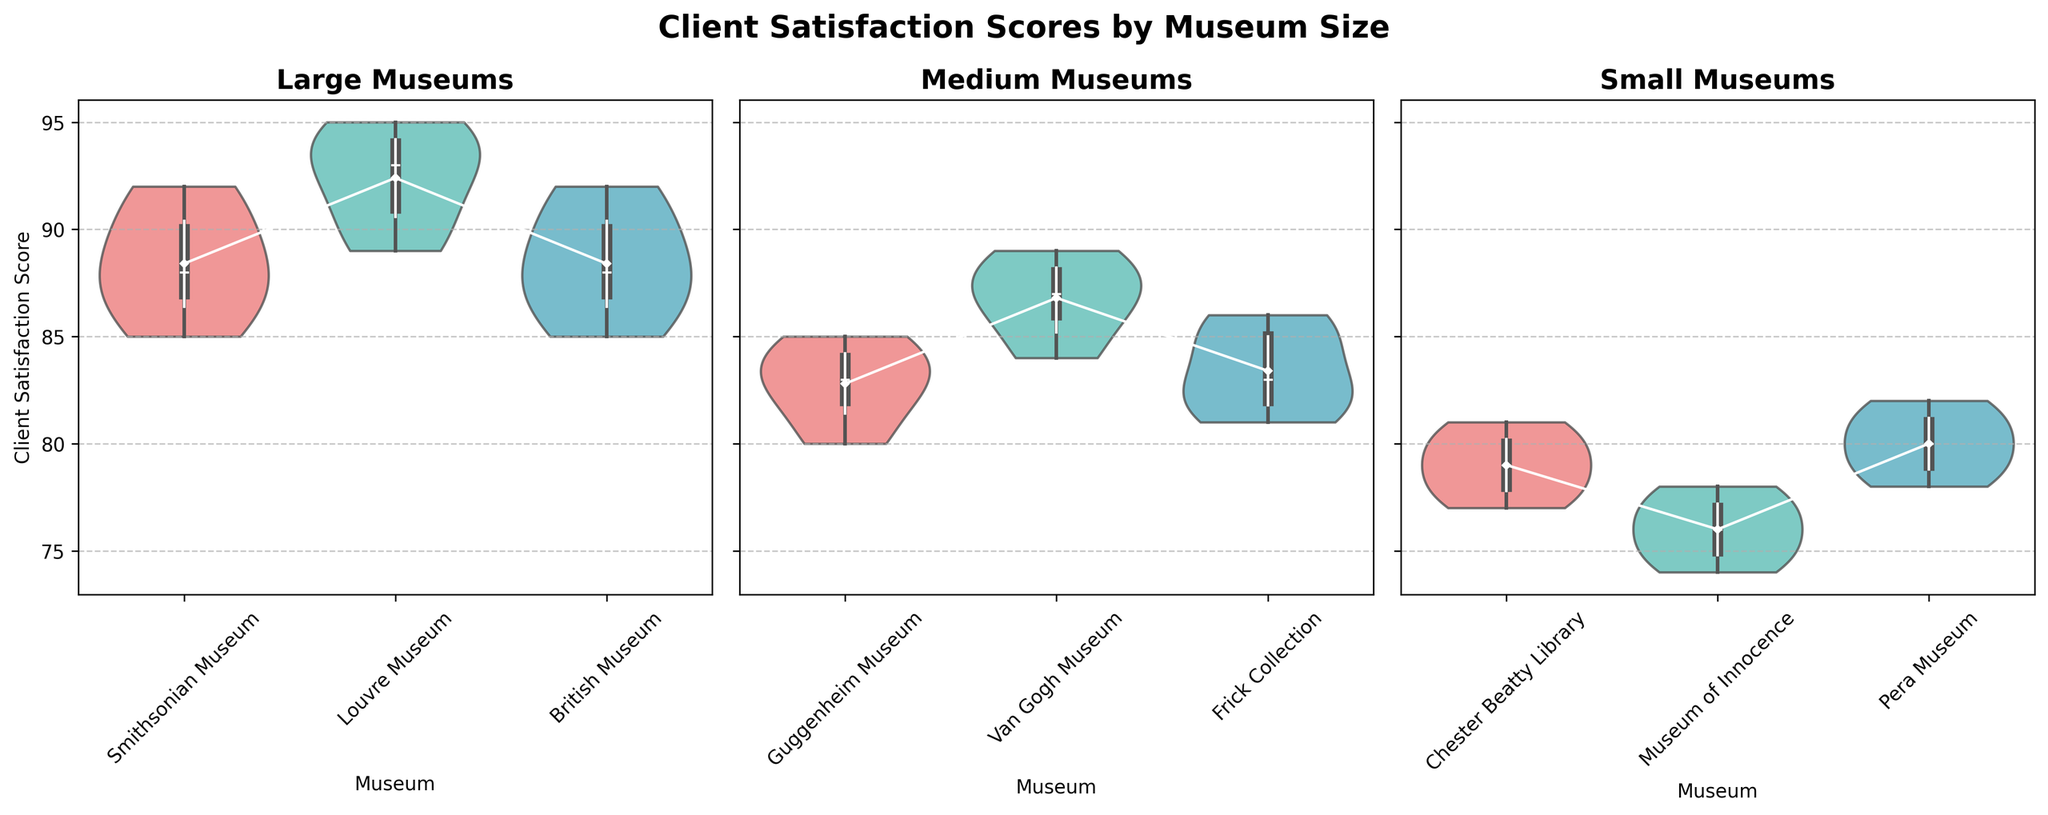What is the title of the plots? The title of the plots is found at the top of the figure. It reads "Client Satisfaction Scores by Museum Size". This indicates that the figure is comparing client satisfaction scores for museums of different sizes.
Answer: Client Satisfaction Scores by Museum Size Which museum among the large museums has the highest average client satisfaction score? To find this, we need to look at the positioning of the white diamonds (mean points) on the "Large Museums" subplot. Among the Smithsonian, Louvre, and British Museum, the Louvre Museum has the highest average, as indicated by the highest mean point.
Answer: Louvre Museum What is the range of client satisfaction scores for medium-sized museums? The range is determined by the minimum and maximum values in the violin plots for medium-sized museums. For the Guggenheim Museum, Van Gogh Museum, and Frick Collection, the minimum score is 80 and the maximum is 89 based on the extreme ends of the plots.
Answer: 80-89 Which museum size has the most varied client satisfaction scores? The variation can be assessed by the width of the violin plots. The small museums have the widest plots and the most spread out distribution of scores across the Chester Beatty Library, Museum of Innocence, and Pera Museum.
Answer: Small museums Do the larger museums tend to have higher client satisfaction scores compared to medium and small-sized museums? By comparing the general positioning of the violin plots, we can observe that the large museums generally have higher scores (mostly in the high 80s and 90s) compared to medium (mostly in 80s) and small museums (mostly in 70s to low 80s).
Answer: Yes Which medium-sized museum has the lowest average client satisfaction score? By checking the mean points (white diamonds) in the "Medium Museums" subplot, the lowest average score is observed in the Frick Collection.
Answer: Frick Collection Is there any overlap in the client satisfaction scores between the large and medium museums? Yes, there is overlap. The lower end of the large museum scores overlaps with the higher end of the medium museum scores, roughly between scores of 85 and 90.
Answer: Yes Which small museum has the highest client satisfaction score? By looking at the maximum values within the small museums' violin plots, the highest score is in the Pera Museum, reaching 82.
Answer: Pera Museum How does the client satisfaction score distribution of the Chester Beatty Library compare to the Smithsonian Museum? The Chester Beatty Library has scores more centered around the 78-81 range, while the Smithsonian Museum's scores are higher and more dispersed from 85 to 92.
Answer: Chester Beatty Library scores lower and less dispersed In which museum size category is the mean score closest to 85? By comparing the positions of the mean points (white diamonds), the mean score for the medium-sized museums is closest to 85.
Answer: Medium 